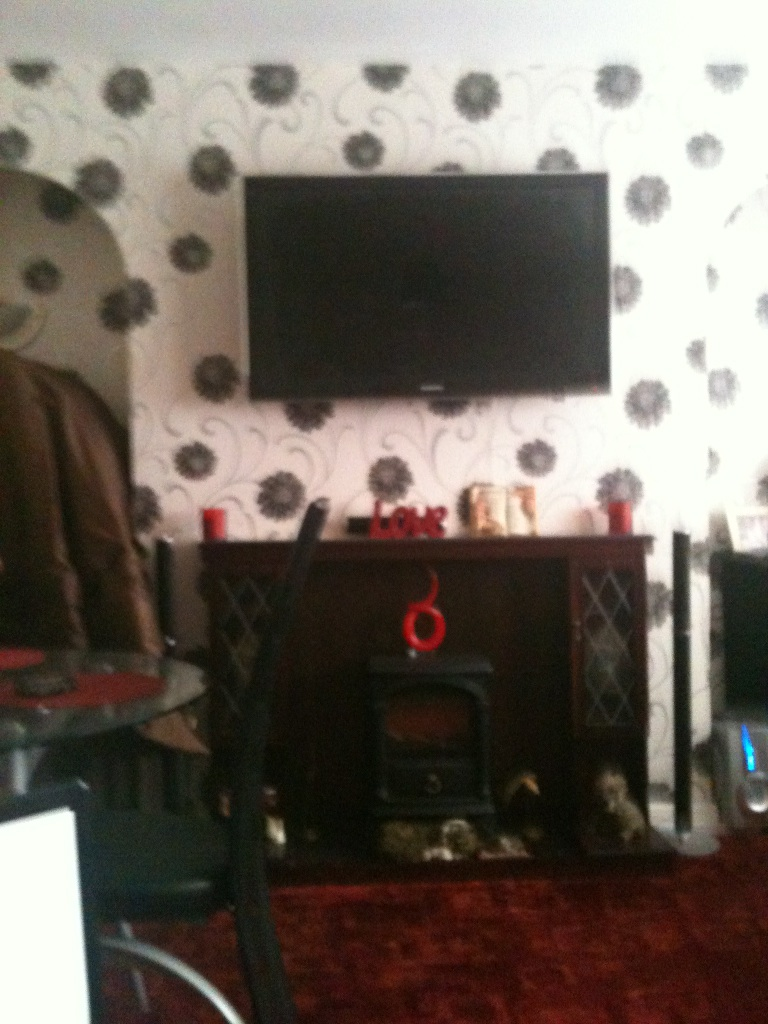What are some of the key elements in this image that stand out? Some key elements that stand out in this image include the large flat-screen television mounted on the wall, the bold floral-patterned wallpaper, and the cozy fireplace below the television. Additionally, there are several decorative items on the mantel and surrounding the fireplace, including a red 'LOVE' sign and a few figurines, which add personal touches to the space. Imagine if the objects in this room could talk. What might they say? If the objects in this room could talk, the television might boast about never missing out on the latest shows and movies, being the centerpiece of entertainment. The fireplace could proudly talk about the countless cozy evenings spent basking in its warmth. The 'LOVE' sign might share stories of affection and family moments, while the decorative figurines could recount tales of being lovingly chosen and placed to complete the room's ambiance. Compose a short story set in this room involving an unexpected event. In the quiet of a winter evening, the Johnson family gathered in their cozy living room. The scent of hot cocoa filled the air as the fireplace crackled softly, casting a warm glow. Suddenly, a soft thud echoed through the room. The 'LOVE' sign on the mantelpiece had toppled over, revealing a hidden compartment behind it. Curiosity piqued, they opened it to find a small, dust-covered box containing an old letter. The letter was dated over fifty years ago, sharing a heartfelt message from a soldier to his beloved. This unexpected discovery revealed a long-forgotten connection to their home, sparking a journey to uncover the history of the house and its previous inhabitants, leading to new friendships and a deeper appreciation for their own family's love and togetherness.  How would you redesign this room to make it more modern and minimalistic? To redesign this room to make it more modern and minimalistic, I would start by repainting the walls in a solid, neutral color like white or light grey to replace the floral wallpaper. I would minimize the number of decorative items, keeping only a few essential and sleek pieces. The fireplace could be updated with a cleaner, more contemporary design, and the furniture could be replaced with simpler, more streamlined pieces. The television could remain as a focal point, but mounted on a more minimalist media console without additional clutter. Finally, adding some subtle lighting solutions, like recessed lighting or modern floor lamps, could enhance the clean and airy feel of the space. 